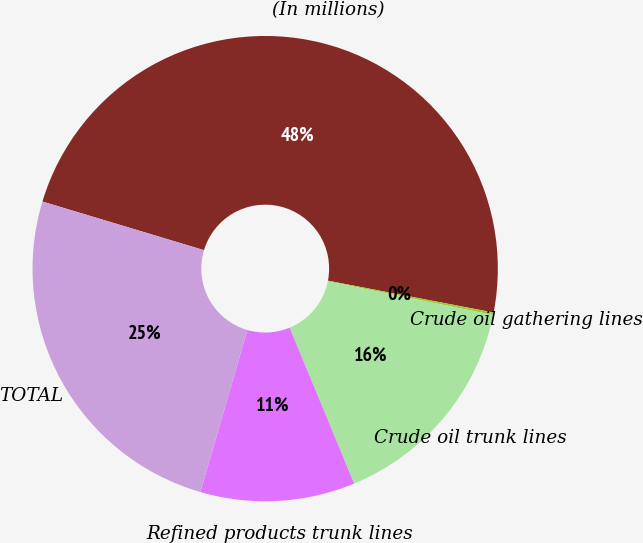<chart> <loc_0><loc_0><loc_500><loc_500><pie_chart><fcel>(In millions)<fcel>Crude oil gathering lines<fcel>Crude oil trunk lines<fcel>Refined products trunk lines<fcel>TOTAL<nl><fcel>48.37%<fcel>0.17%<fcel>15.56%<fcel>10.74%<fcel>25.16%<nl></chart> 